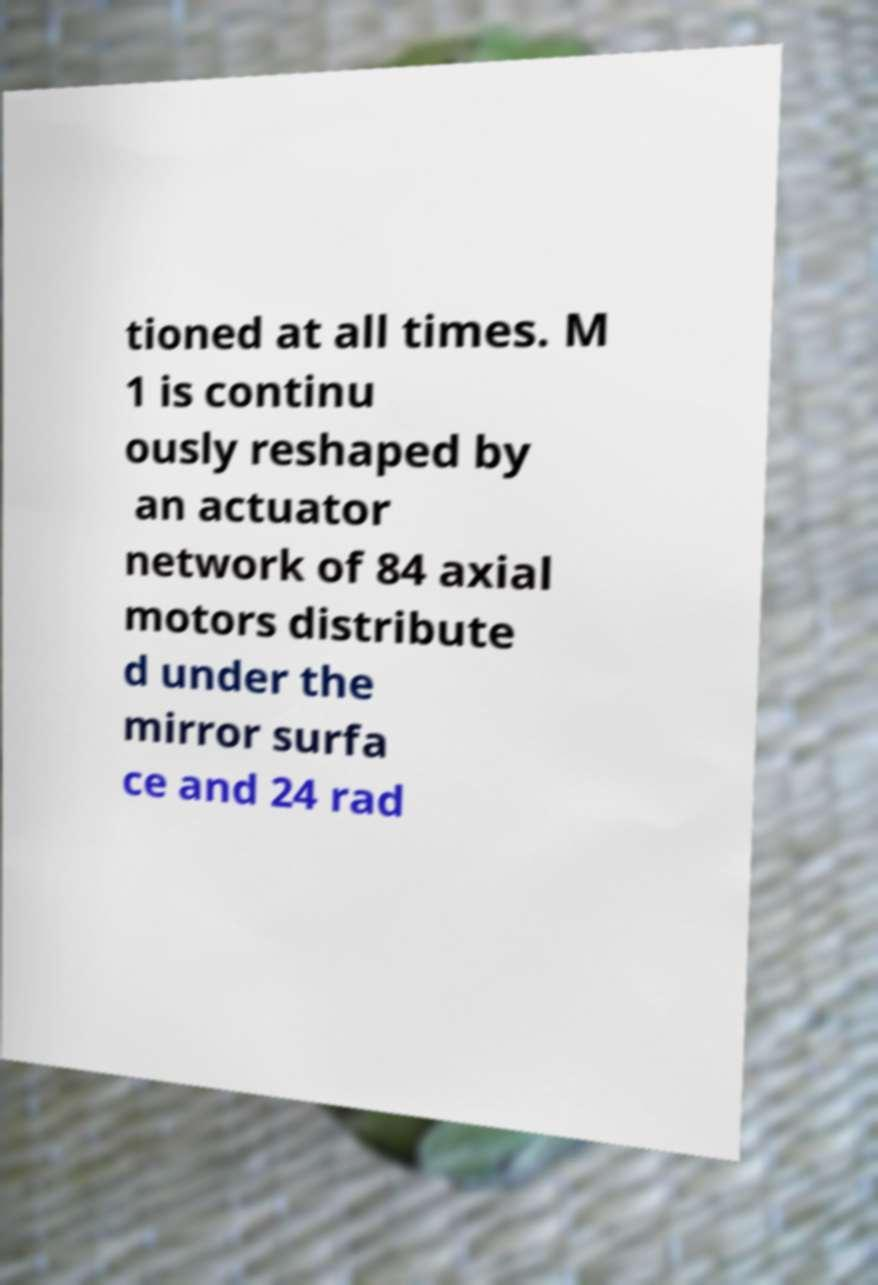There's text embedded in this image that I need extracted. Can you transcribe it verbatim? tioned at all times. M 1 is continu ously reshaped by an actuator network of 84 axial motors distribute d under the mirror surfa ce and 24 rad 